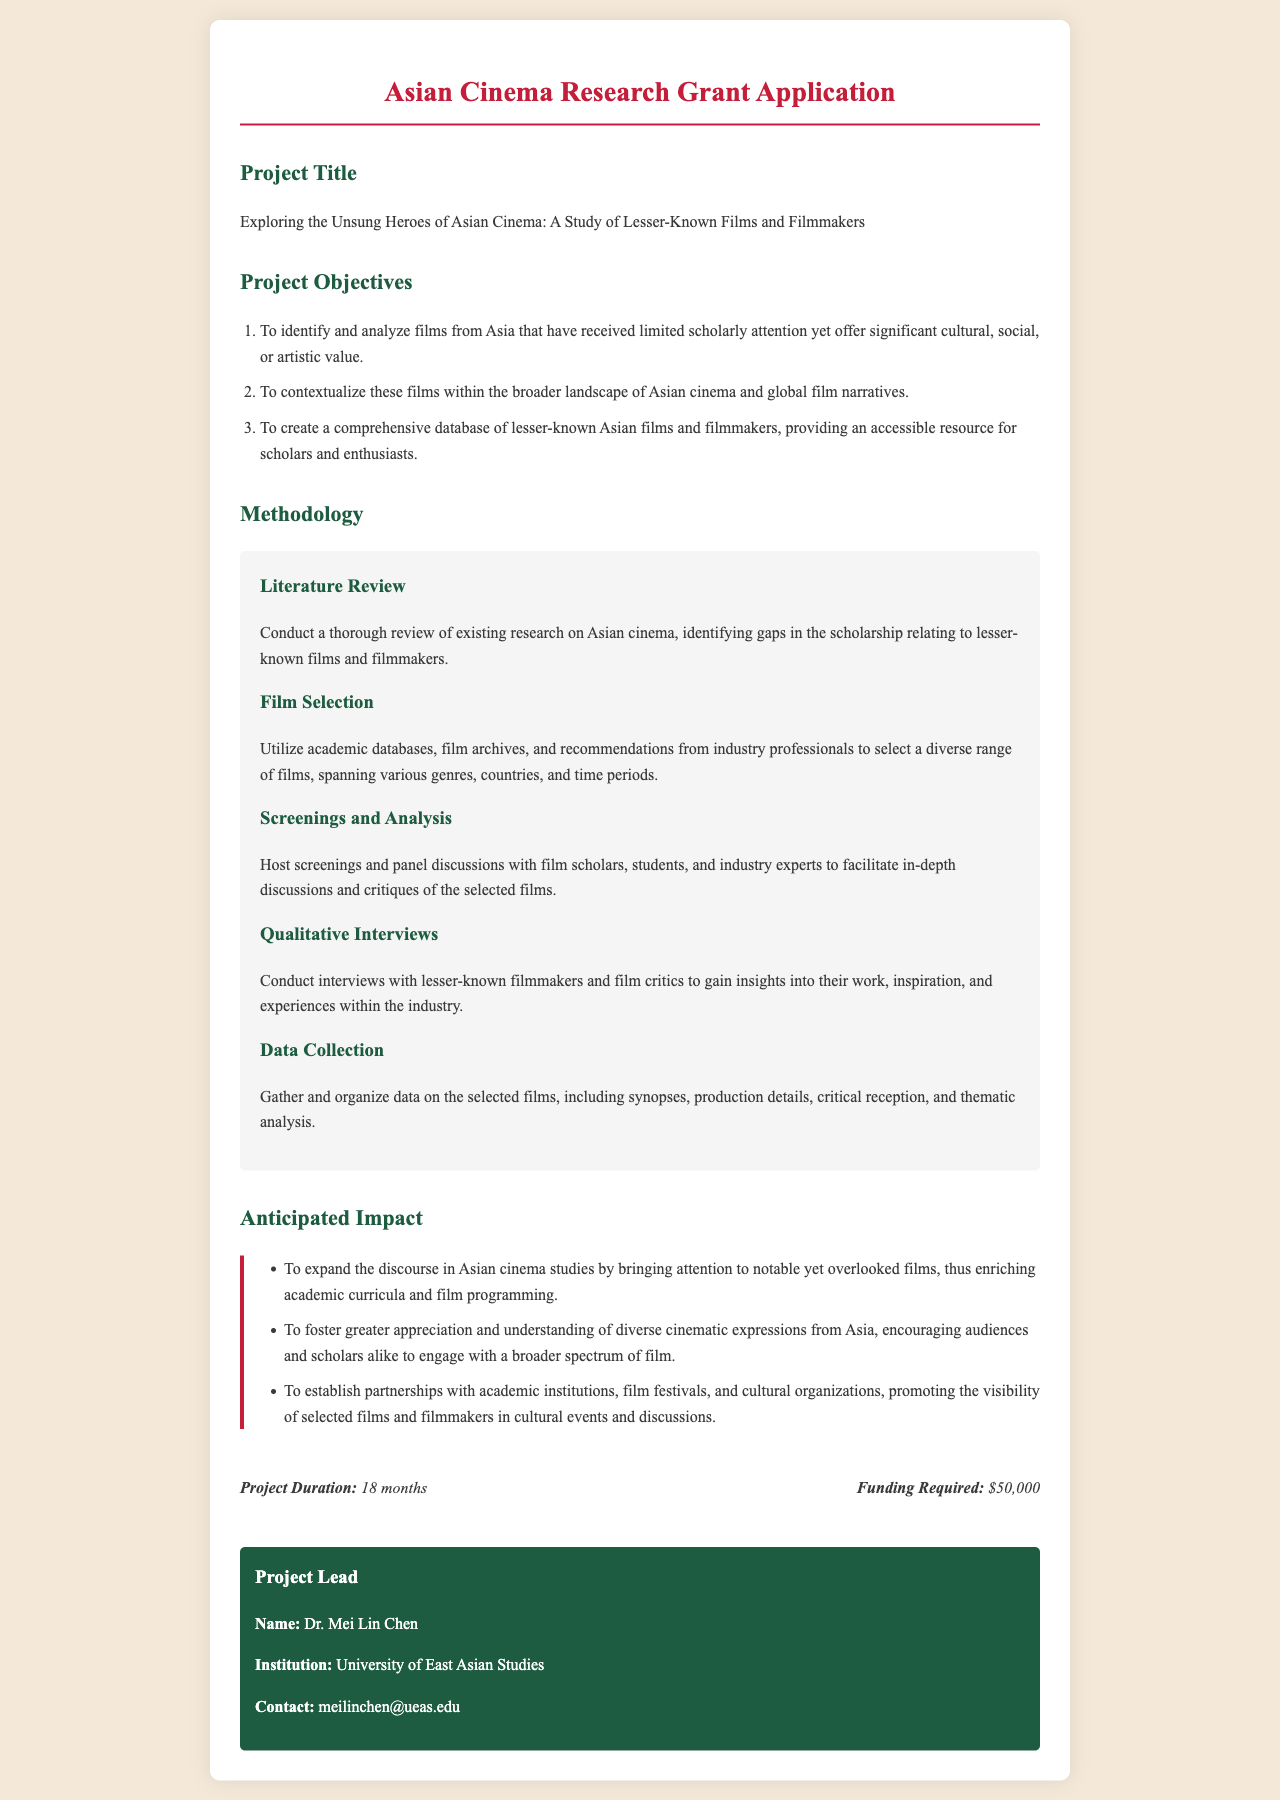What is the project title? The project title is explicitly stated in the document under the respective section.
Answer: Exploring the Unsung Heroes of Asian Cinema: A Study of Lesser-Known Films and Filmmakers How many project objectives are listed? The number of project objectives can be inferred from the numbered list provided in the document.
Answer: 3 What is the funding required for the project? The funding required is directly mentioned in the project information section of the document.
Answer: $50,000 Who is the project lead? The project lead's name is presented in the designated section of the document, clearly labeling it.
Answer: Dr. Mei Lin Chen What is the duration of the project? The document specifies the project duration in the project information section.
Answer: 18 months What methodology involves hosting screenings? The specific methodology that involves hosting screenings is described under a particular subheading in the document.
Answer: Screenings and Analysis What is one anticipated impact of the project? The anticipated impacts are listed in a bullet format, highlighting the key contributions of the project.
Answer: Expand the discourse in Asian cinema studies What type of interviews will be conducted? The document outlines the type of qualitative engagement expected in the project methodology.
Answer: Qualitative Interviews 